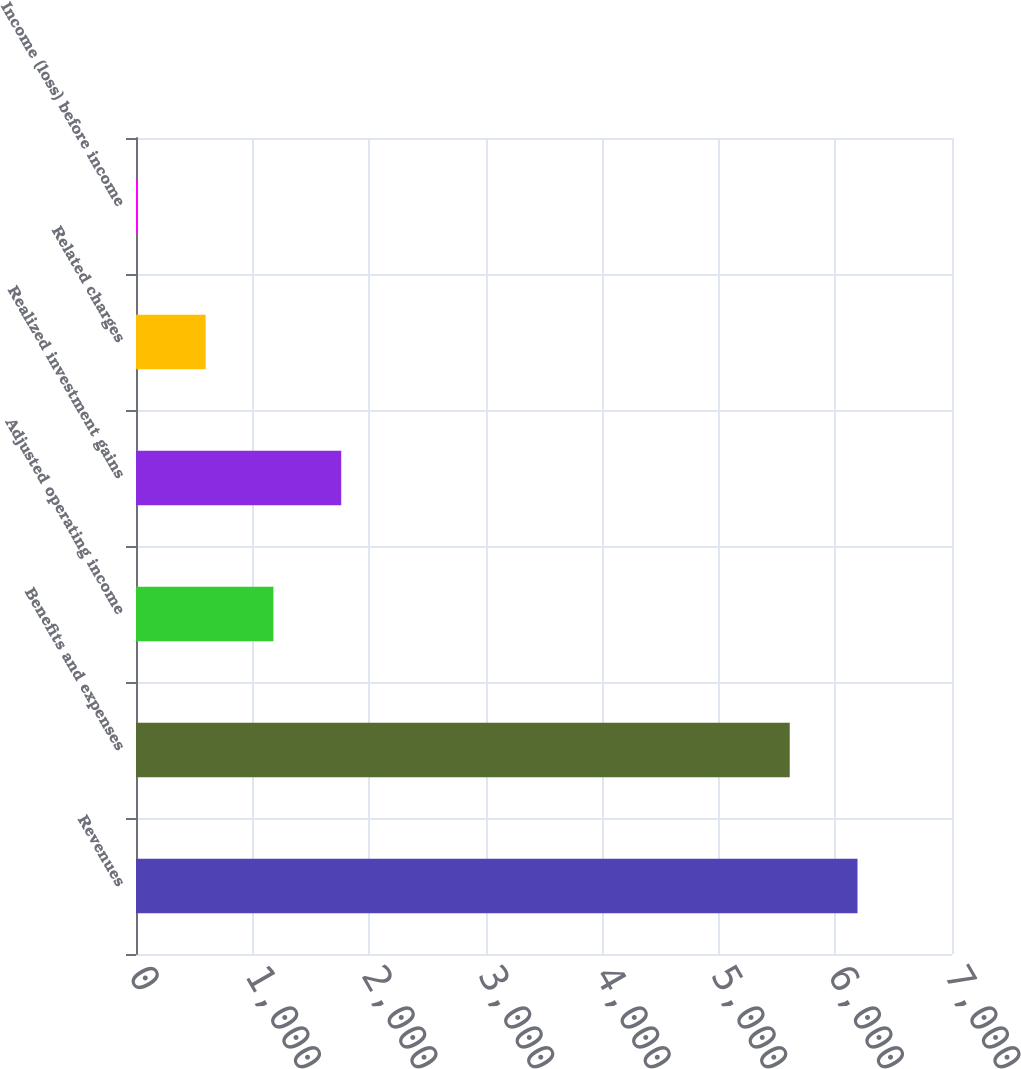Convert chart to OTSL. <chart><loc_0><loc_0><loc_500><loc_500><bar_chart><fcel>Revenues<fcel>Benefits and expenses<fcel>Adjusted operating income<fcel>Realized investment gains<fcel>Related charges<fcel>Income (loss) before income<nl><fcel>6189.5<fcel>5608<fcel>1179<fcel>1760.5<fcel>597.5<fcel>16<nl></chart> 